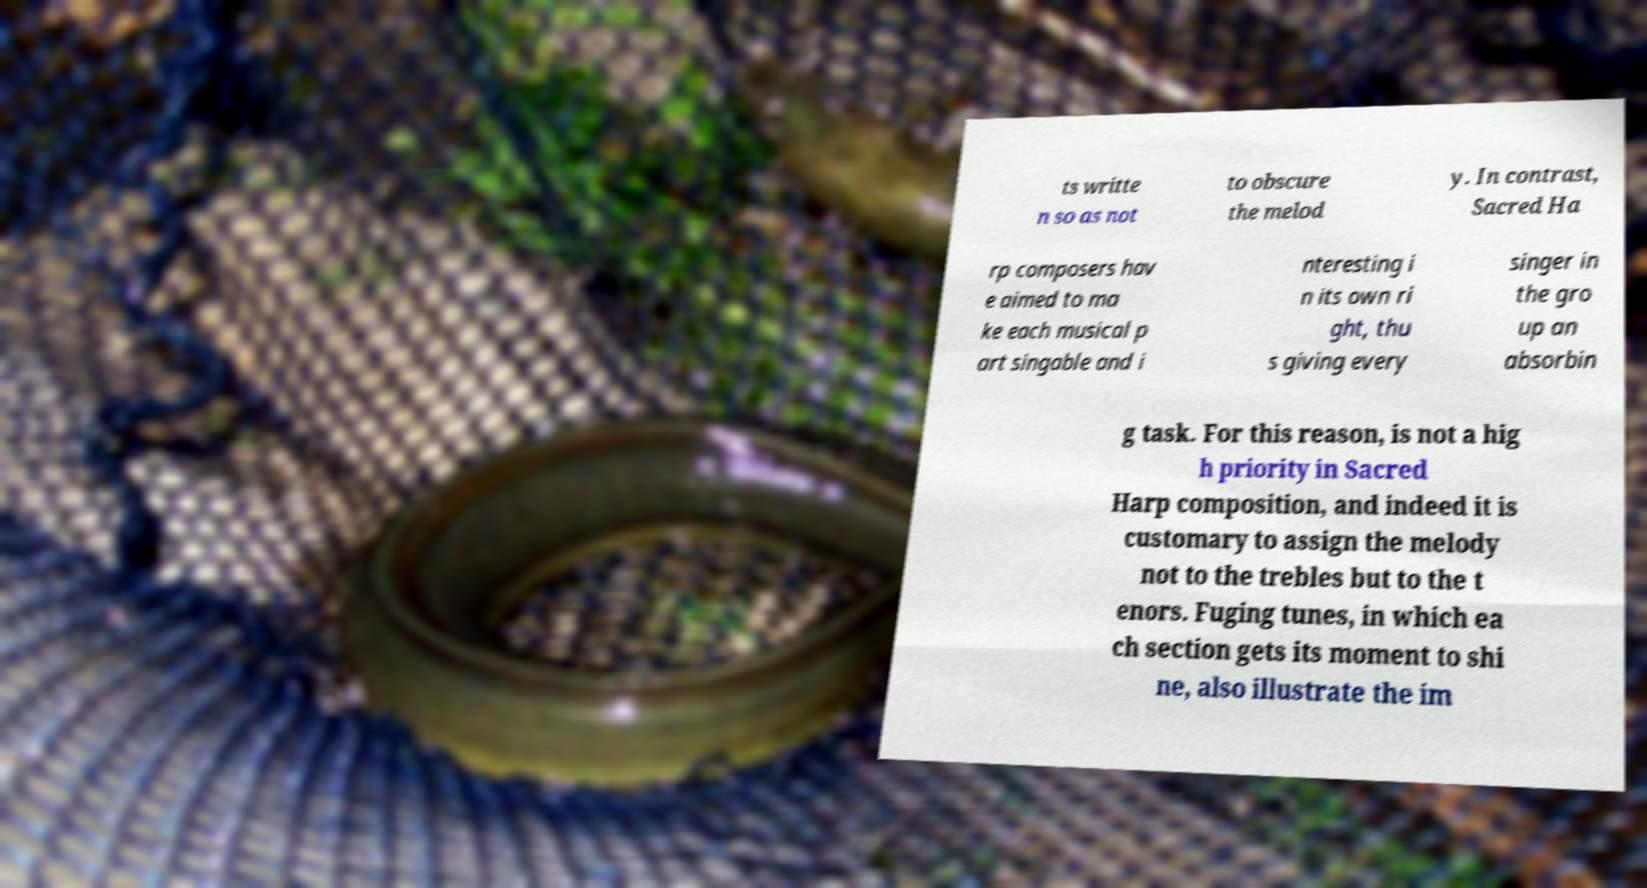Please read and relay the text visible in this image. What does it say? ts writte n so as not to obscure the melod y. In contrast, Sacred Ha rp composers hav e aimed to ma ke each musical p art singable and i nteresting i n its own ri ght, thu s giving every singer in the gro up an absorbin g task. For this reason, is not a hig h priority in Sacred Harp composition, and indeed it is customary to assign the melody not to the trebles but to the t enors. Fuging tunes, in which ea ch section gets its moment to shi ne, also illustrate the im 